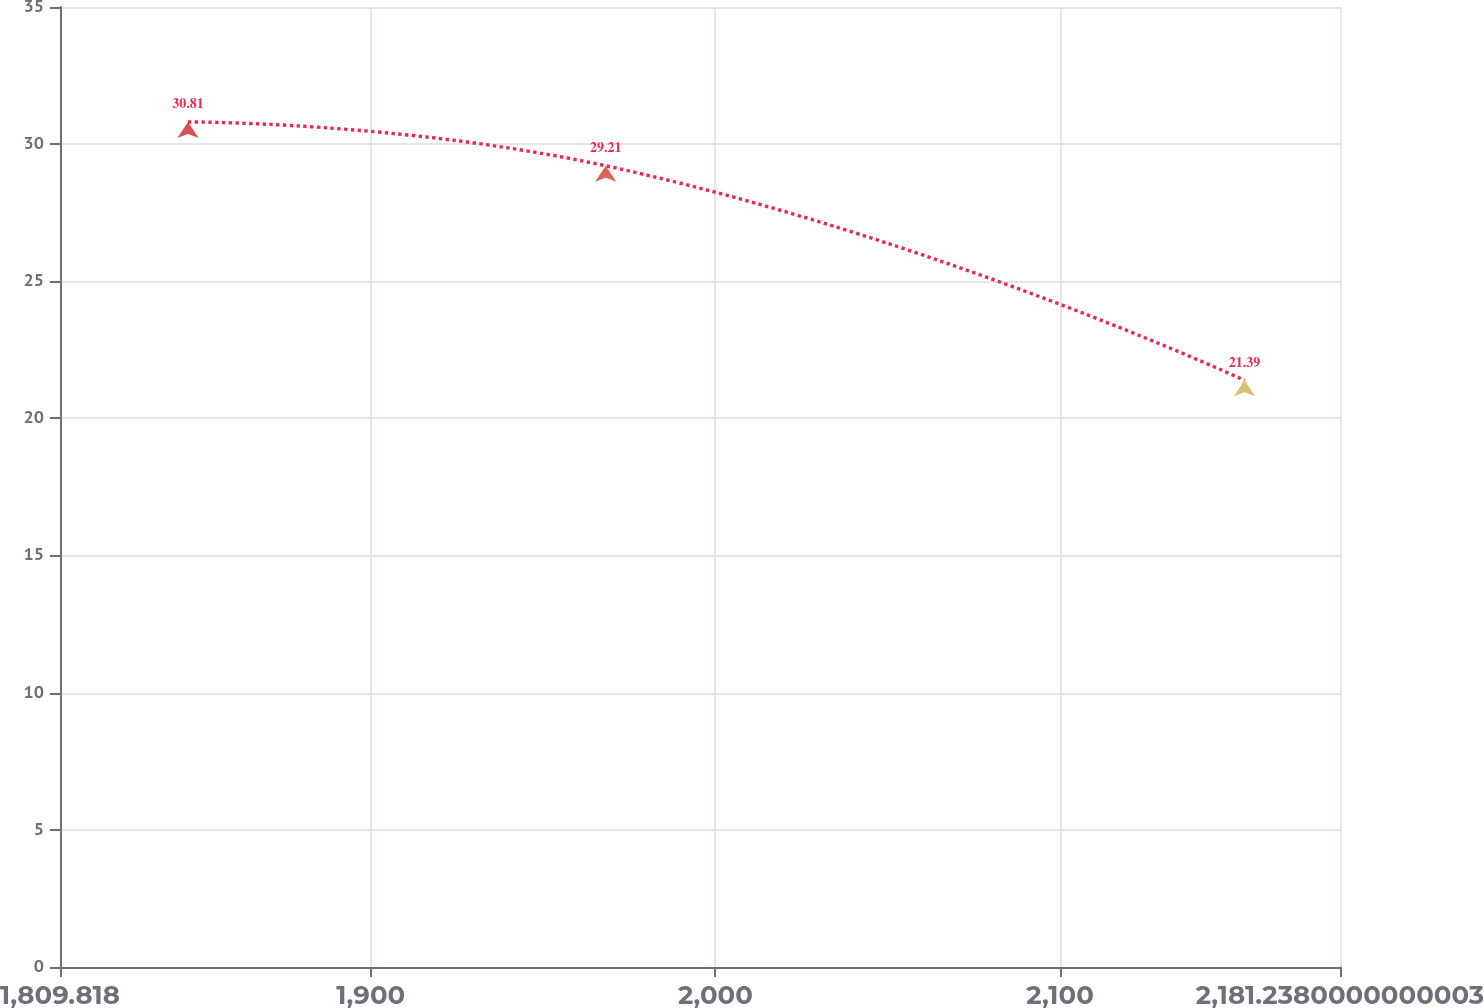<chart> <loc_0><loc_0><loc_500><loc_500><line_chart><ecel><fcel>Unnamed: 1<nl><fcel>1846.96<fcel>30.81<nl><fcel>1968.18<fcel>29.21<nl><fcel>2153.54<fcel>21.39<nl><fcel>2185.96<fcel>19.79<nl><fcel>2218.38<fcel>14.32<nl></chart> 